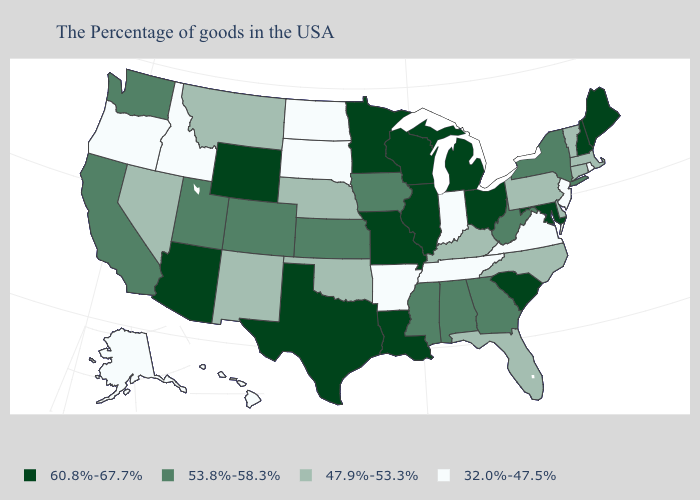Which states have the lowest value in the USA?
Concise answer only. Rhode Island, New Jersey, Virginia, Indiana, Tennessee, Arkansas, South Dakota, North Dakota, Idaho, Oregon, Alaska, Hawaii. Which states have the lowest value in the MidWest?
Concise answer only. Indiana, South Dakota, North Dakota. Name the states that have a value in the range 60.8%-67.7%?
Be succinct. Maine, New Hampshire, Maryland, South Carolina, Ohio, Michigan, Wisconsin, Illinois, Louisiana, Missouri, Minnesota, Texas, Wyoming, Arizona. Which states hav the highest value in the MidWest?
Be succinct. Ohio, Michigan, Wisconsin, Illinois, Missouri, Minnesota. What is the value of New Hampshire?
Give a very brief answer. 60.8%-67.7%. How many symbols are there in the legend?
Be succinct. 4. What is the value of Florida?
Give a very brief answer. 47.9%-53.3%. What is the value of New Mexico?
Answer briefly. 47.9%-53.3%. What is the lowest value in states that border California?
Be succinct. 32.0%-47.5%. Among the states that border Massachusetts , does New Hampshire have the highest value?
Write a very short answer. Yes. Does the first symbol in the legend represent the smallest category?
Short answer required. No. Does Wisconsin have the lowest value in the MidWest?
Quick response, please. No. Name the states that have a value in the range 32.0%-47.5%?
Quick response, please. Rhode Island, New Jersey, Virginia, Indiana, Tennessee, Arkansas, South Dakota, North Dakota, Idaho, Oregon, Alaska, Hawaii. Name the states that have a value in the range 53.8%-58.3%?
Quick response, please. New York, West Virginia, Georgia, Alabama, Mississippi, Iowa, Kansas, Colorado, Utah, California, Washington. 